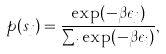<formula> <loc_0><loc_0><loc_500><loc_500>p ( s _ { j } ) = \frac { \exp ( - \beta \epsilon _ { j } ) } { \sum _ { i } \exp ( - \beta \epsilon _ { i } ) } ,</formula> 